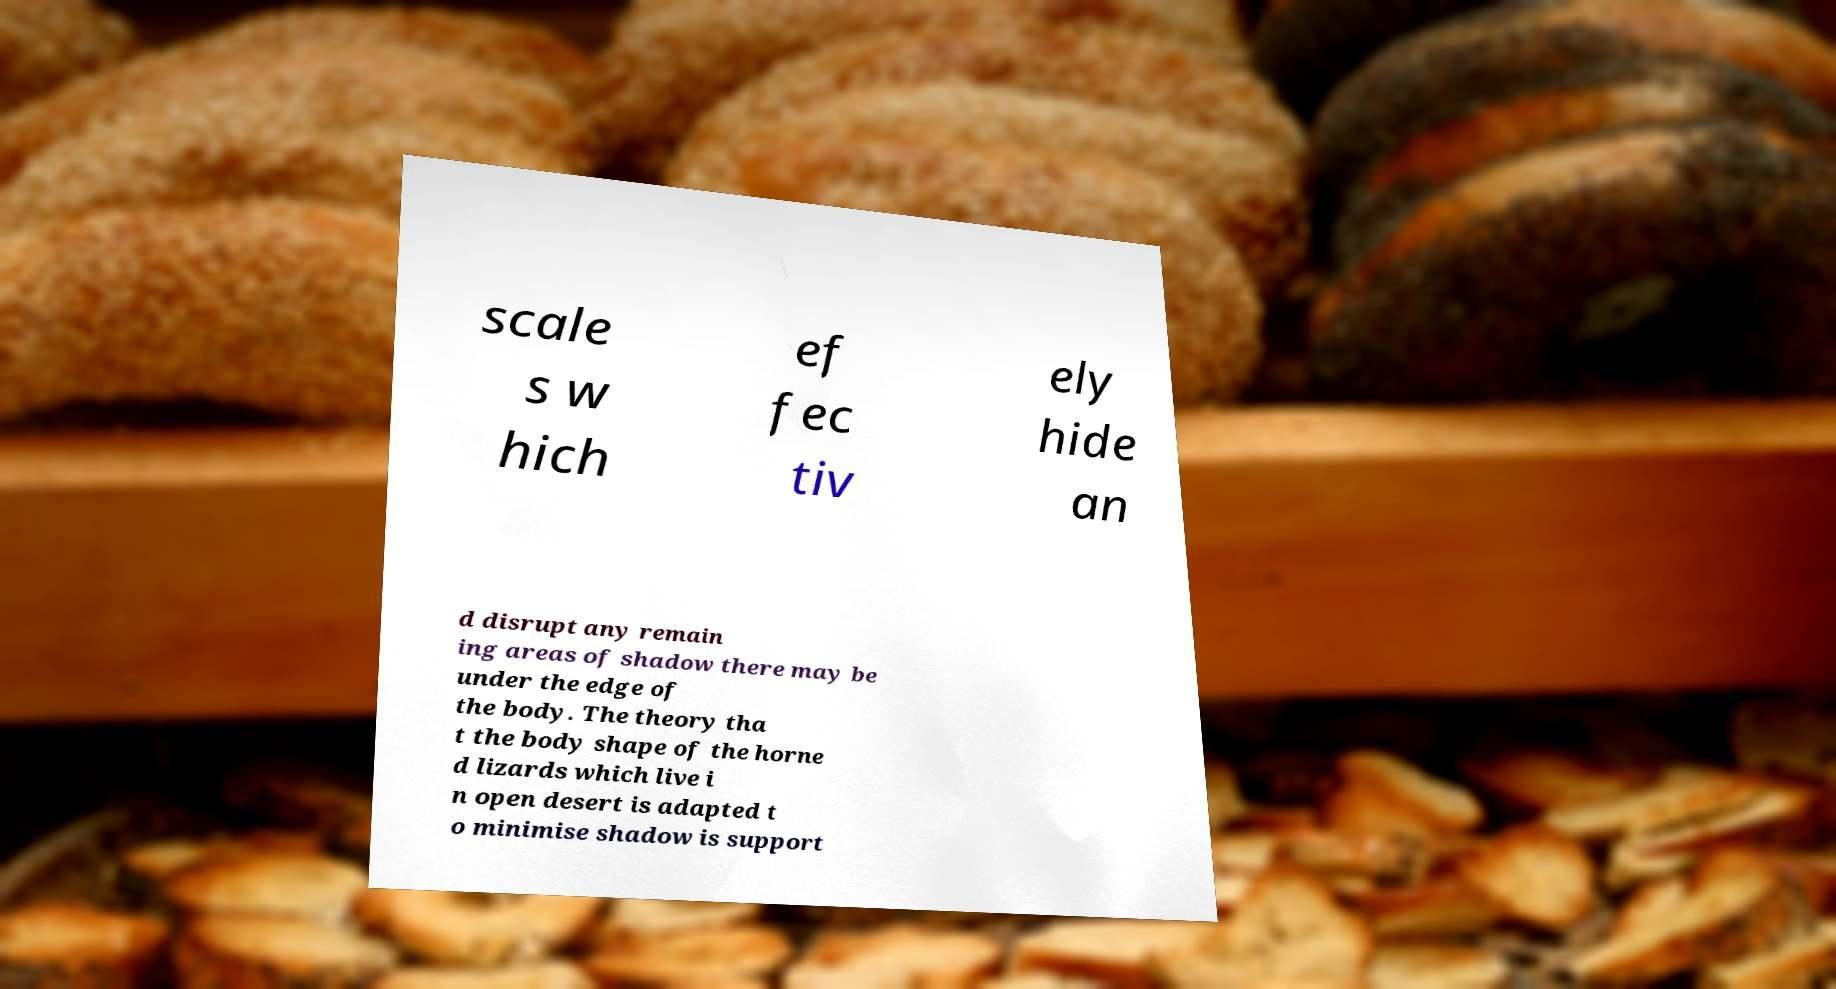Please read and relay the text visible in this image. What does it say? scale s w hich ef fec tiv ely hide an d disrupt any remain ing areas of shadow there may be under the edge of the body. The theory tha t the body shape of the horne d lizards which live i n open desert is adapted t o minimise shadow is support 